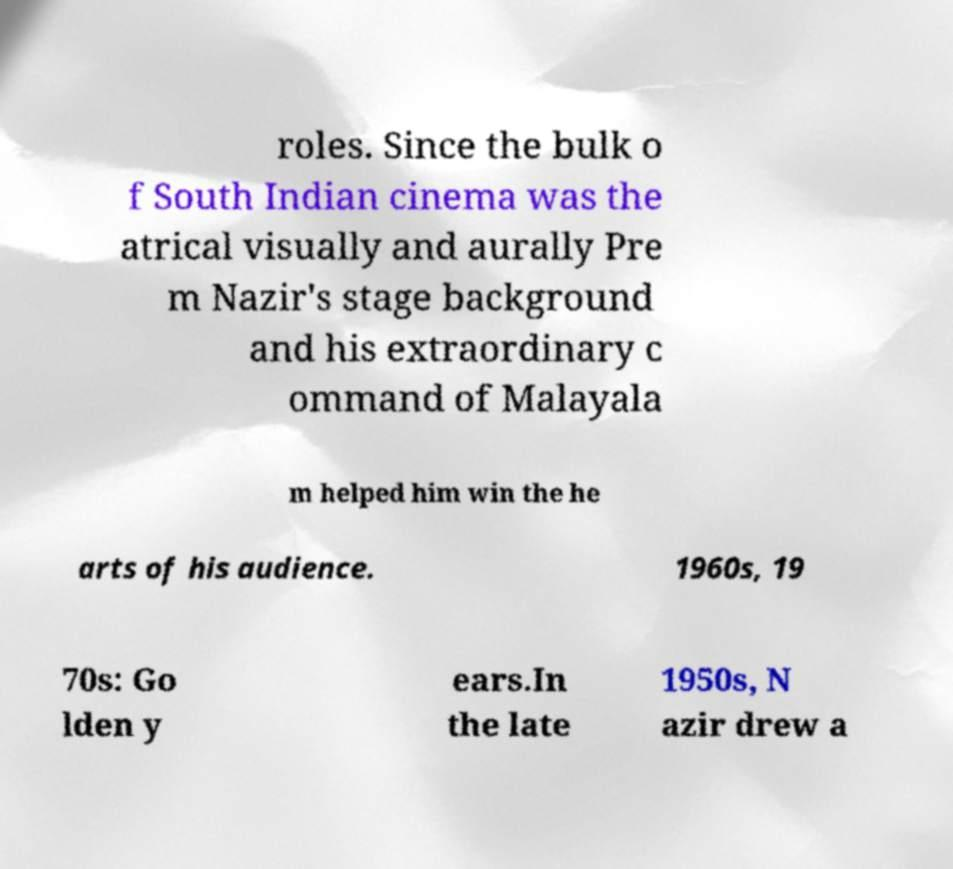There's text embedded in this image that I need extracted. Can you transcribe it verbatim? roles. Since the bulk o f South Indian cinema was the atrical visually and aurally Pre m Nazir's stage background and his extraordinary c ommand of Malayala m helped him win the he arts of his audience. 1960s, 19 70s: Go lden y ears.In the late 1950s, N azir drew a 